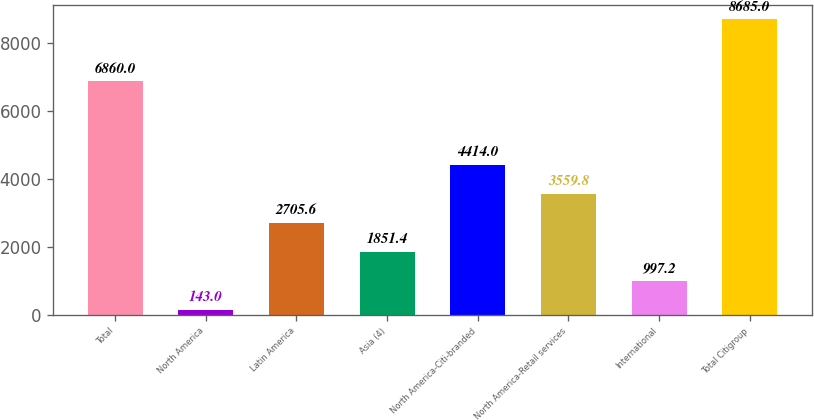<chart> <loc_0><loc_0><loc_500><loc_500><bar_chart><fcel>Total<fcel>North America<fcel>Latin America<fcel>Asia (4)<fcel>North America-Citi-branded<fcel>North America-Retail services<fcel>International<fcel>Total Citigroup<nl><fcel>6860<fcel>143<fcel>2705.6<fcel>1851.4<fcel>4414<fcel>3559.8<fcel>997.2<fcel>8685<nl></chart> 